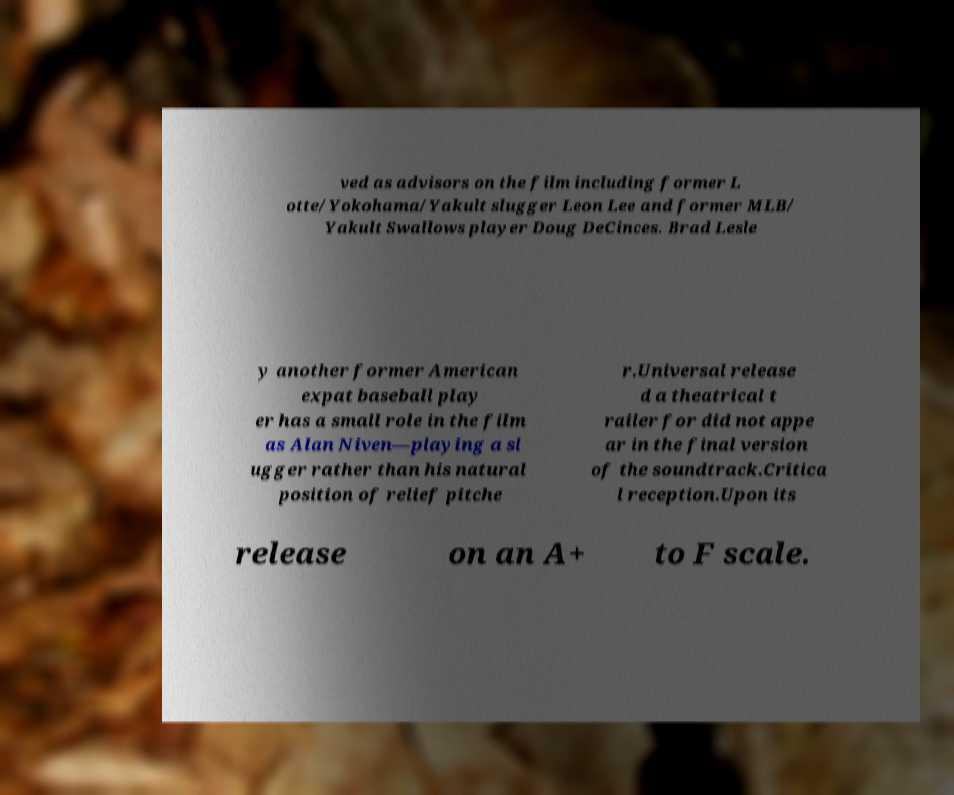Can you accurately transcribe the text from the provided image for me? ved as advisors on the film including former L otte/Yokohama/Yakult slugger Leon Lee and former MLB/ Yakult Swallows player Doug DeCinces. Brad Lesle y another former American expat baseball play er has a small role in the film as Alan Niven—playing a sl ugger rather than his natural position of relief pitche r.Universal release d a theatrical t railer for did not appe ar in the final version of the soundtrack.Critica l reception.Upon its release on an A+ to F scale. 